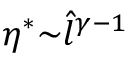<formula> <loc_0><loc_0><loc_500><loc_500>\eta ^ { * } { \sim } \hat { l } ^ { \gamma - 1 }</formula> 